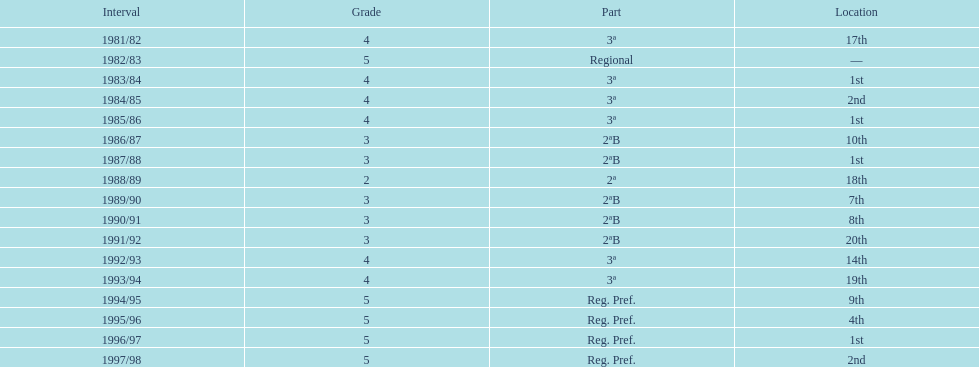What year has no place indicated? 1982/83. 